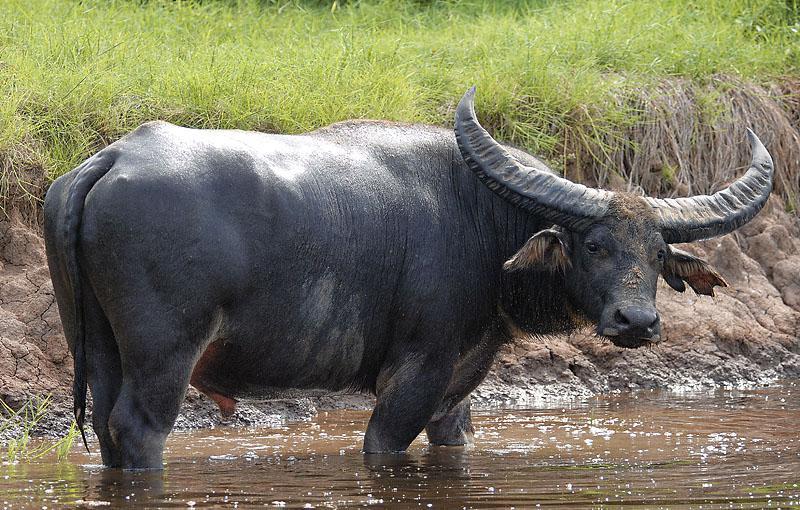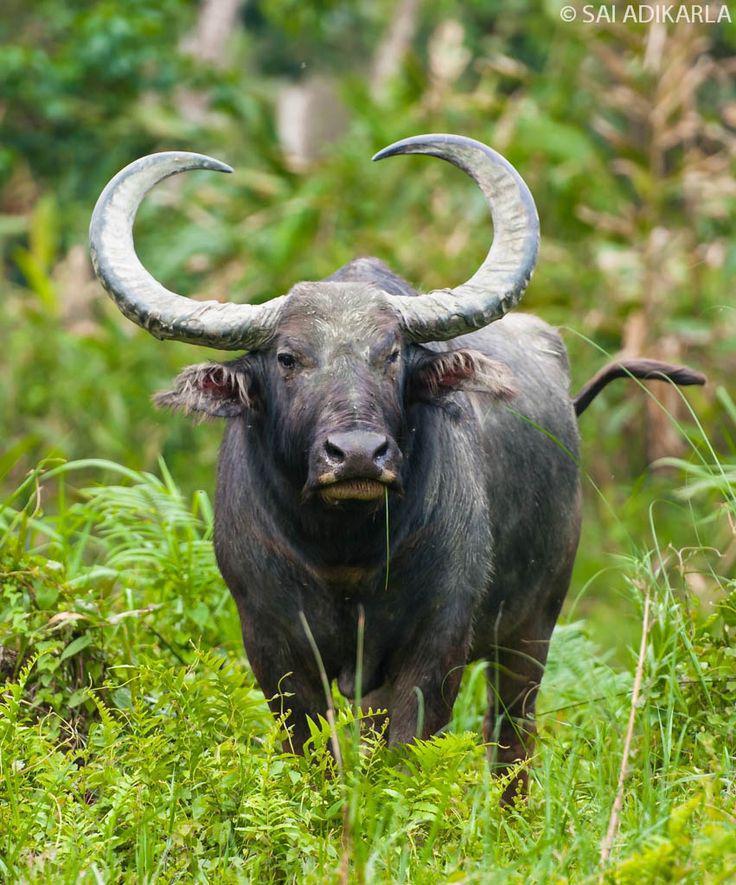The first image is the image on the left, the second image is the image on the right. Analyze the images presented: Is the assertion "One of the images contains one baby water buffalo." valid? Answer yes or no. No. 